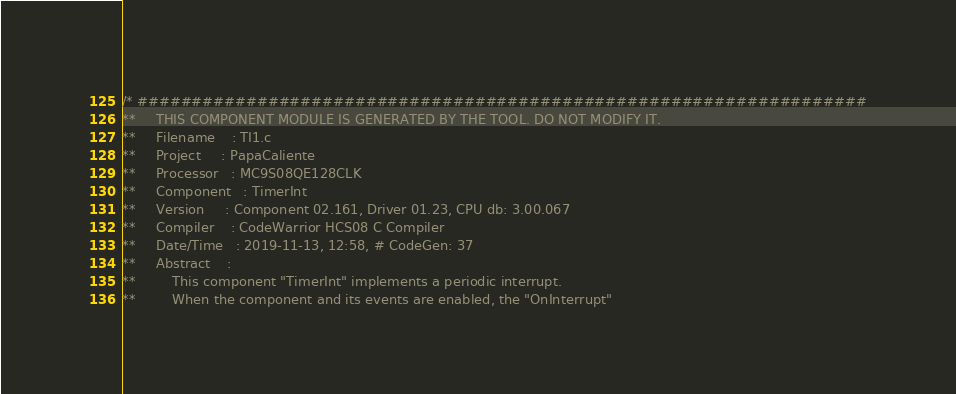<code> <loc_0><loc_0><loc_500><loc_500><_C_>/* ###################################################################
**     THIS COMPONENT MODULE IS GENERATED BY THE TOOL. DO NOT MODIFY IT.
**     Filename    : TI1.c
**     Project     : PapaCaliente
**     Processor   : MC9S08QE128CLK
**     Component   : TimerInt
**     Version     : Component 02.161, Driver 01.23, CPU db: 3.00.067
**     Compiler    : CodeWarrior HCS08 C Compiler
**     Date/Time   : 2019-11-13, 12:58, # CodeGen: 37
**     Abstract    :
**         This component "TimerInt" implements a periodic interrupt.
**         When the component and its events are enabled, the "OnInterrupt"</code> 